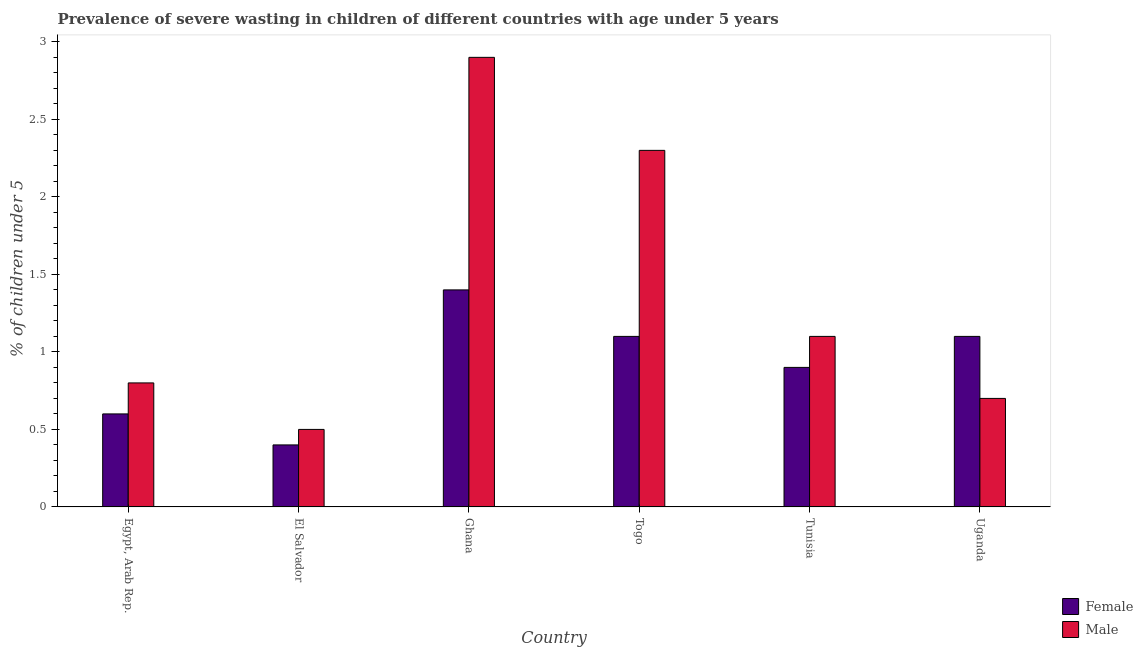How many different coloured bars are there?
Offer a terse response. 2. How many bars are there on the 1st tick from the left?
Offer a very short reply. 2. How many bars are there on the 1st tick from the right?
Keep it short and to the point. 2. What is the label of the 2nd group of bars from the left?
Provide a short and direct response. El Salvador. In how many cases, is the number of bars for a given country not equal to the number of legend labels?
Your response must be concise. 0. What is the percentage of undernourished male children in Togo?
Provide a succinct answer. 2.3. Across all countries, what is the maximum percentage of undernourished male children?
Provide a succinct answer. 2.9. In which country was the percentage of undernourished male children minimum?
Give a very brief answer. El Salvador. What is the total percentage of undernourished female children in the graph?
Ensure brevity in your answer.  5.5. What is the difference between the percentage of undernourished female children in Egypt, Arab Rep. and that in Uganda?
Offer a very short reply. -0.5. What is the difference between the percentage of undernourished female children in Uganda and the percentage of undernourished male children in Egypt, Arab Rep.?
Provide a succinct answer. 0.3. What is the average percentage of undernourished male children per country?
Ensure brevity in your answer.  1.38. What is the difference between the percentage of undernourished female children and percentage of undernourished male children in Togo?
Keep it short and to the point. -1.2. In how many countries, is the percentage of undernourished female children greater than 1.7 %?
Your answer should be compact. 0. What is the ratio of the percentage of undernourished female children in Togo to that in Uganda?
Keep it short and to the point. 1. Is the percentage of undernourished female children in Togo less than that in Tunisia?
Your answer should be very brief. No. Is the difference between the percentage of undernourished male children in Ghana and Togo greater than the difference between the percentage of undernourished female children in Ghana and Togo?
Provide a succinct answer. Yes. What is the difference between the highest and the second highest percentage of undernourished male children?
Your response must be concise. 0.6. What is the difference between the highest and the lowest percentage of undernourished female children?
Provide a short and direct response. 1. Is the sum of the percentage of undernourished female children in El Salvador and Ghana greater than the maximum percentage of undernourished male children across all countries?
Your answer should be very brief. No. What does the 2nd bar from the left in Ghana represents?
Give a very brief answer. Male. What does the 1st bar from the right in Togo represents?
Offer a terse response. Male. How many bars are there?
Your response must be concise. 12. Are all the bars in the graph horizontal?
Provide a short and direct response. No. How many countries are there in the graph?
Keep it short and to the point. 6. Are the values on the major ticks of Y-axis written in scientific E-notation?
Give a very brief answer. No. Does the graph contain any zero values?
Your answer should be very brief. No. Does the graph contain grids?
Keep it short and to the point. No. How are the legend labels stacked?
Provide a succinct answer. Vertical. What is the title of the graph?
Offer a terse response. Prevalence of severe wasting in children of different countries with age under 5 years. What is the label or title of the X-axis?
Your response must be concise. Country. What is the label or title of the Y-axis?
Provide a short and direct response.  % of children under 5. What is the  % of children under 5 of Female in Egypt, Arab Rep.?
Offer a terse response. 0.6. What is the  % of children under 5 in Male in Egypt, Arab Rep.?
Provide a short and direct response. 0.8. What is the  % of children under 5 of Female in El Salvador?
Ensure brevity in your answer.  0.4. What is the  % of children under 5 of Female in Ghana?
Offer a very short reply. 1.4. What is the  % of children under 5 of Male in Ghana?
Offer a very short reply. 2.9. What is the  % of children under 5 of Female in Togo?
Offer a terse response. 1.1. What is the  % of children under 5 in Male in Togo?
Offer a terse response. 2.3. What is the  % of children under 5 in Female in Tunisia?
Your answer should be compact. 0.9. What is the  % of children under 5 of Male in Tunisia?
Your answer should be very brief. 1.1. What is the  % of children under 5 of Female in Uganda?
Provide a short and direct response. 1.1. What is the  % of children under 5 of Male in Uganda?
Provide a short and direct response. 0.7. Across all countries, what is the maximum  % of children under 5 in Female?
Offer a terse response. 1.4. Across all countries, what is the maximum  % of children under 5 of Male?
Make the answer very short. 2.9. Across all countries, what is the minimum  % of children under 5 of Female?
Give a very brief answer. 0.4. What is the total  % of children under 5 of Male in the graph?
Give a very brief answer. 8.3. What is the difference between the  % of children under 5 of Female in Egypt, Arab Rep. and that in El Salvador?
Provide a succinct answer. 0.2. What is the difference between the  % of children under 5 of Male in Egypt, Arab Rep. and that in El Salvador?
Ensure brevity in your answer.  0.3. What is the difference between the  % of children under 5 in Female in Egypt, Arab Rep. and that in Ghana?
Offer a terse response. -0.8. What is the difference between the  % of children under 5 of Female in Egypt, Arab Rep. and that in Tunisia?
Offer a terse response. -0.3. What is the difference between the  % of children under 5 in Male in Egypt, Arab Rep. and that in Tunisia?
Provide a succinct answer. -0.3. What is the difference between the  % of children under 5 of Male in El Salvador and that in Ghana?
Provide a short and direct response. -2.4. What is the difference between the  % of children under 5 in Female in El Salvador and that in Tunisia?
Provide a succinct answer. -0.5. What is the difference between the  % of children under 5 of Male in El Salvador and that in Tunisia?
Make the answer very short. -0.6. What is the difference between the  % of children under 5 in Female in El Salvador and that in Uganda?
Provide a short and direct response. -0.7. What is the difference between the  % of children under 5 of Male in El Salvador and that in Uganda?
Your answer should be compact. -0.2. What is the difference between the  % of children under 5 in Female in Ghana and that in Togo?
Keep it short and to the point. 0.3. What is the difference between the  % of children under 5 of Female in Ghana and that in Uganda?
Provide a succinct answer. 0.3. What is the difference between the  % of children under 5 in Female in Togo and that in Tunisia?
Give a very brief answer. 0.2. What is the difference between the  % of children under 5 in Male in Togo and that in Tunisia?
Your response must be concise. 1.2. What is the difference between the  % of children under 5 of Female in Tunisia and that in Uganda?
Offer a very short reply. -0.2. What is the difference between the  % of children under 5 of Male in Tunisia and that in Uganda?
Your answer should be very brief. 0.4. What is the difference between the  % of children under 5 in Female in Egypt, Arab Rep. and the  % of children under 5 in Male in El Salvador?
Your response must be concise. 0.1. What is the difference between the  % of children under 5 of Female in Egypt, Arab Rep. and the  % of children under 5 of Male in Togo?
Your answer should be very brief. -1.7. What is the difference between the  % of children under 5 of Female in Egypt, Arab Rep. and the  % of children under 5 of Male in Tunisia?
Your response must be concise. -0.5. What is the difference between the  % of children under 5 of Female in Egypt, Arab Rep. and the  % of children under 5 of Male in Uganda?
Your answer should be very brief. -0.1. What is the difference between the  % of children under 5 of Female in El Salvador and the  % of children under 5 of Male in Tunisia?
Make the answer very short. -0.7. What is the difference between the  % of children under 5 of Female in Ghana and the  % of children under 5 of Male in Uganda?
Offer a terse response. 0.7. What is the difference between the  % of children under 5 of Female in Togo and the  % of children under 5 of Male in Tunisia?
Make the answer very short. 0. What is the difference between the  % of children under 5 of Female in Togo and the  % of children under 5 of Male in Uganda?
Offer a terse response. 0.4. What is the average  % of children under 5 of Male per country?
Make the answer very short. 1.38. What is the difference between the  % of children under 5 of Female and  % of children under 5 of Male in Egypt, Arab Rep.?
Provide a succinct answer. -0.2. What is the difference between the  % of children under 5 in Female and  % of children under 5 in Male in El Salvador?
Keep it short and to the point. -0.1. What is the ratio of the  % of children under 5 of Female in Egypt, Arab Rep. to that in Ghana?
Ensure brevity in your answer.  0.43. What is the ratio of the  % of children under 5 of Male in Egypt, Arab Rep. to that in Ghana?
Make the answer very short. 0.28. What is the ratio of the  % of children under 5 in Female in Egypt, Arab Rep. to that in Togo?
Your answer should be very brief. 0.55. What is the ratio of the  % of children under 5 in Male in Egypt, Arab Rep. to that in Togo?
Provide a succinct answer. 0.35. What is the ratio of the  % of children under 5 of Female in Egypt, Arab Rep. to that in Tunisia?
Give a very brief answer. 0.67. What is the ratio of the  % of children under 5 in Male in Egypt, Arab Rep. to that in Tunisia?
Offer a very short reply. 0.73. What is the ratio of the  % of children under 5 of Female in Egypt, Arab Rep. to that in Uganda?
Provide a short and direct response. 0.55. What is the ratio of the  % of children under 5 of Male in Egypt, Arab Rep. to that in Uganda?
Offer a very short reply. 1.14. What is the ratio of the  % of children under 5 in Female in El Salvador to that in Ghana?
Keep it short and to the point. 0.29. What is the ratio of the  % of children under 5 in Male in El Salvador to that in Ghana?
Your answer should be compact. 0.17. What is the ratio of the  % of children under 5 in Female in El Salvador to that in Togo?
Keep it short and to the point. 0.36. What is the ratio of the  % of children under 5 of Male in El Salvador to that in Togo?
Keep it short and to the point. 0.22. What is the ratio of the  % of children under 5 in Female in El Salvador to that in Tunisia?
Your answer should be compact. 0.44. What is the ratio of the  % of children under 5 of Male in El Salvador to that in Tunisia?
Provide a succinct answer. 0.45. What is the ratio of the  % of children under 5 in Female in El Salvador to that in Uganda?
Your answer should be compact. 0.36. What is the ratio of the  % of children under 5 in Female in Ghana to that in Togo?
Offer a terse response. 1.27. What is the ratio of the  % of children under 5 in Male in Ghana to that in Togo?
Provide a short and direct response. 1.26. What is the ratio of the  % of children under 5 of Female in Ghana to that in Tunisia?
Your response must be concise. 1.56. What is the ratio of the  % of children under 5 of Male in Ghana to that in Tunisia?
Your response must be concise. 2.64. What is the ratio of the  % of children under 5 of Female in Ghana to that in Uganda?
Offer a terse response. 1.27. What is the ratio of the  % of children under 5 of Male in Ghana to that in Uganda?
Ensure brevity in your answer.  4.14. What is the ratio of the  % of children under 5 in Female in Togo to that in Tunisia?
Offer a very short reply. 1.22. What is the ratio of the  % of children under 5 in Male in Togo to that in Tunisia?
Provide a short and direct response. 2.09. What is the ratio of the  % of children under 5 in Male in Togo to that in Uganda?
Your answer should be compact. 3.29. What is the ratio of the  % of children under 5 in Female in Tunisia to that in Uganda?
Keep it short and to the point. 0.82. What is the ratio of the  % of children under 5 in Male in Tunisia to that in Uganda?
Ensure brevity in your answer.  1.57. What is the difference between the highest and the lowest  % of children under 5 of Male?
Offer a very short reply. 2.4. 